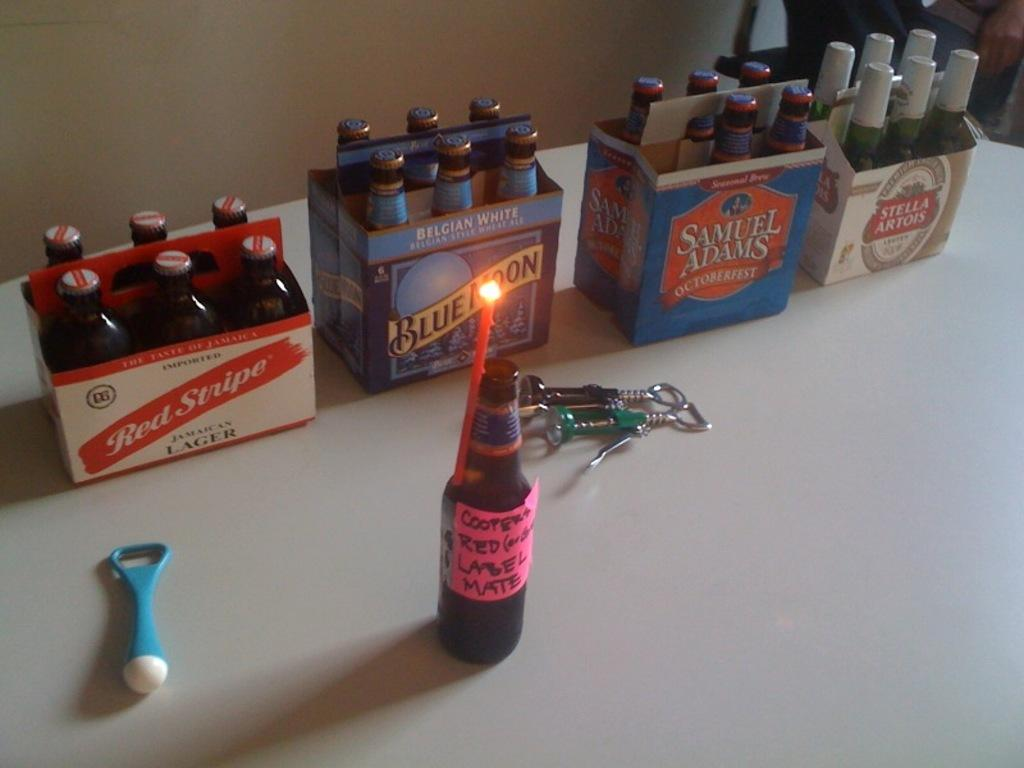<image>
Give a short and clear explanation of the subsequent image. Six packs of bottle sit in a row including Red Stripe and Blue Moon brands. 